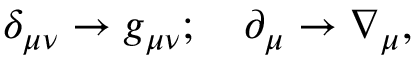<formula> <loc_0><loc_0><loc_500><loc_500>\begin{array} { r } { \delta _ { \mu \nu } \rightarrow g _ { \mu \nu } ; \quad \partial _ { \mu } \rightarrow \nabla _ { \mu } , } \end{array}</formula> 